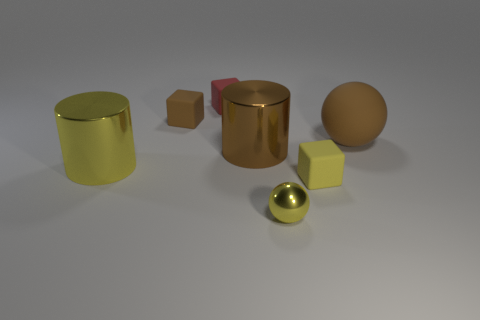What is the material of the cylinder that is the same color as the tiny ball?
Offer a terse response. Metal. Do the block that is in front of the rubber ball and the red block have the same size?
Give a very brief answer. Yes. Are there any large gray spheres made of the same material as the small brown cube?
Make the answer very short. No. How many objects are tiny objects behind the big brown metal thing or large cyan rubber cubes?
Keep it short and to the point. 2. Are there any green shiny cubes?
Keep it short and to the point. No. There is a object that is in front of the small brown matte cube and left of the tiny red object; what shape is it?
Keep it short and to the point. Cylinder. There is a brown object that is left of the red object; what size is it?
Provide a succinct answer. Small. Is the color of the small matte thing in front of the big brown shiny cylinder the same as the small metallic object?
Keep it short and to the point. Yes. What number of red objects have the same shape as the small brown matte thing?
Keep it short and to the point. 1. How many things are brown matte things that are left of the large brown sphere or shiny objects that are to the right of the big brown cylinder?
Your answer should be compact. 2. 